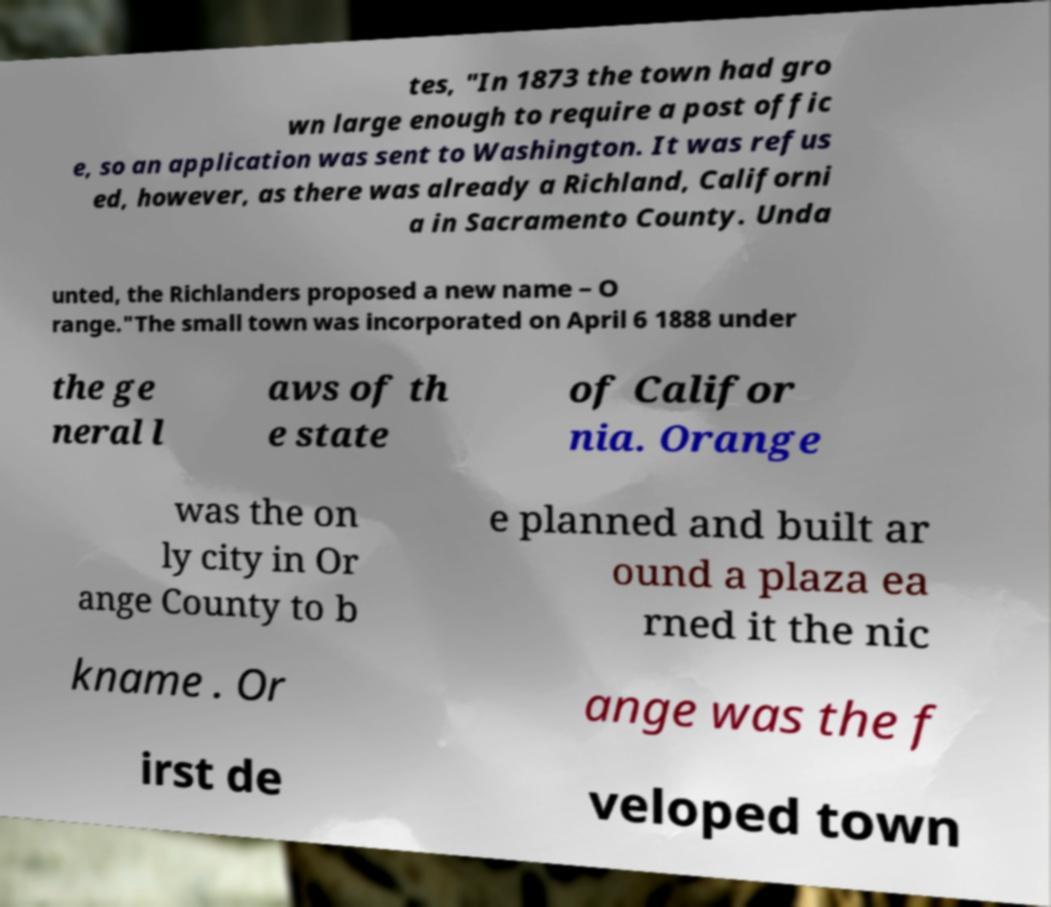Could you assist in decoding the text presented in this image and type it out clearly? tes, "In 1873 the town had gro wn large enough to require a post offic e, so an application was sent to Washington. It was refus ed, however, as there was already a Richland, Californi a in Sacramento County. Unda unted, the Richlanders proposed a new name – O range."The small town was incorporated on April 6 1888 under the ge neral l aws of th e state of Califor nia. Orange was the on ly city in Or ange County to b e planned and built ar ound a plaza ea rned it the nic kname . Or ange was the f irst de veloped town 